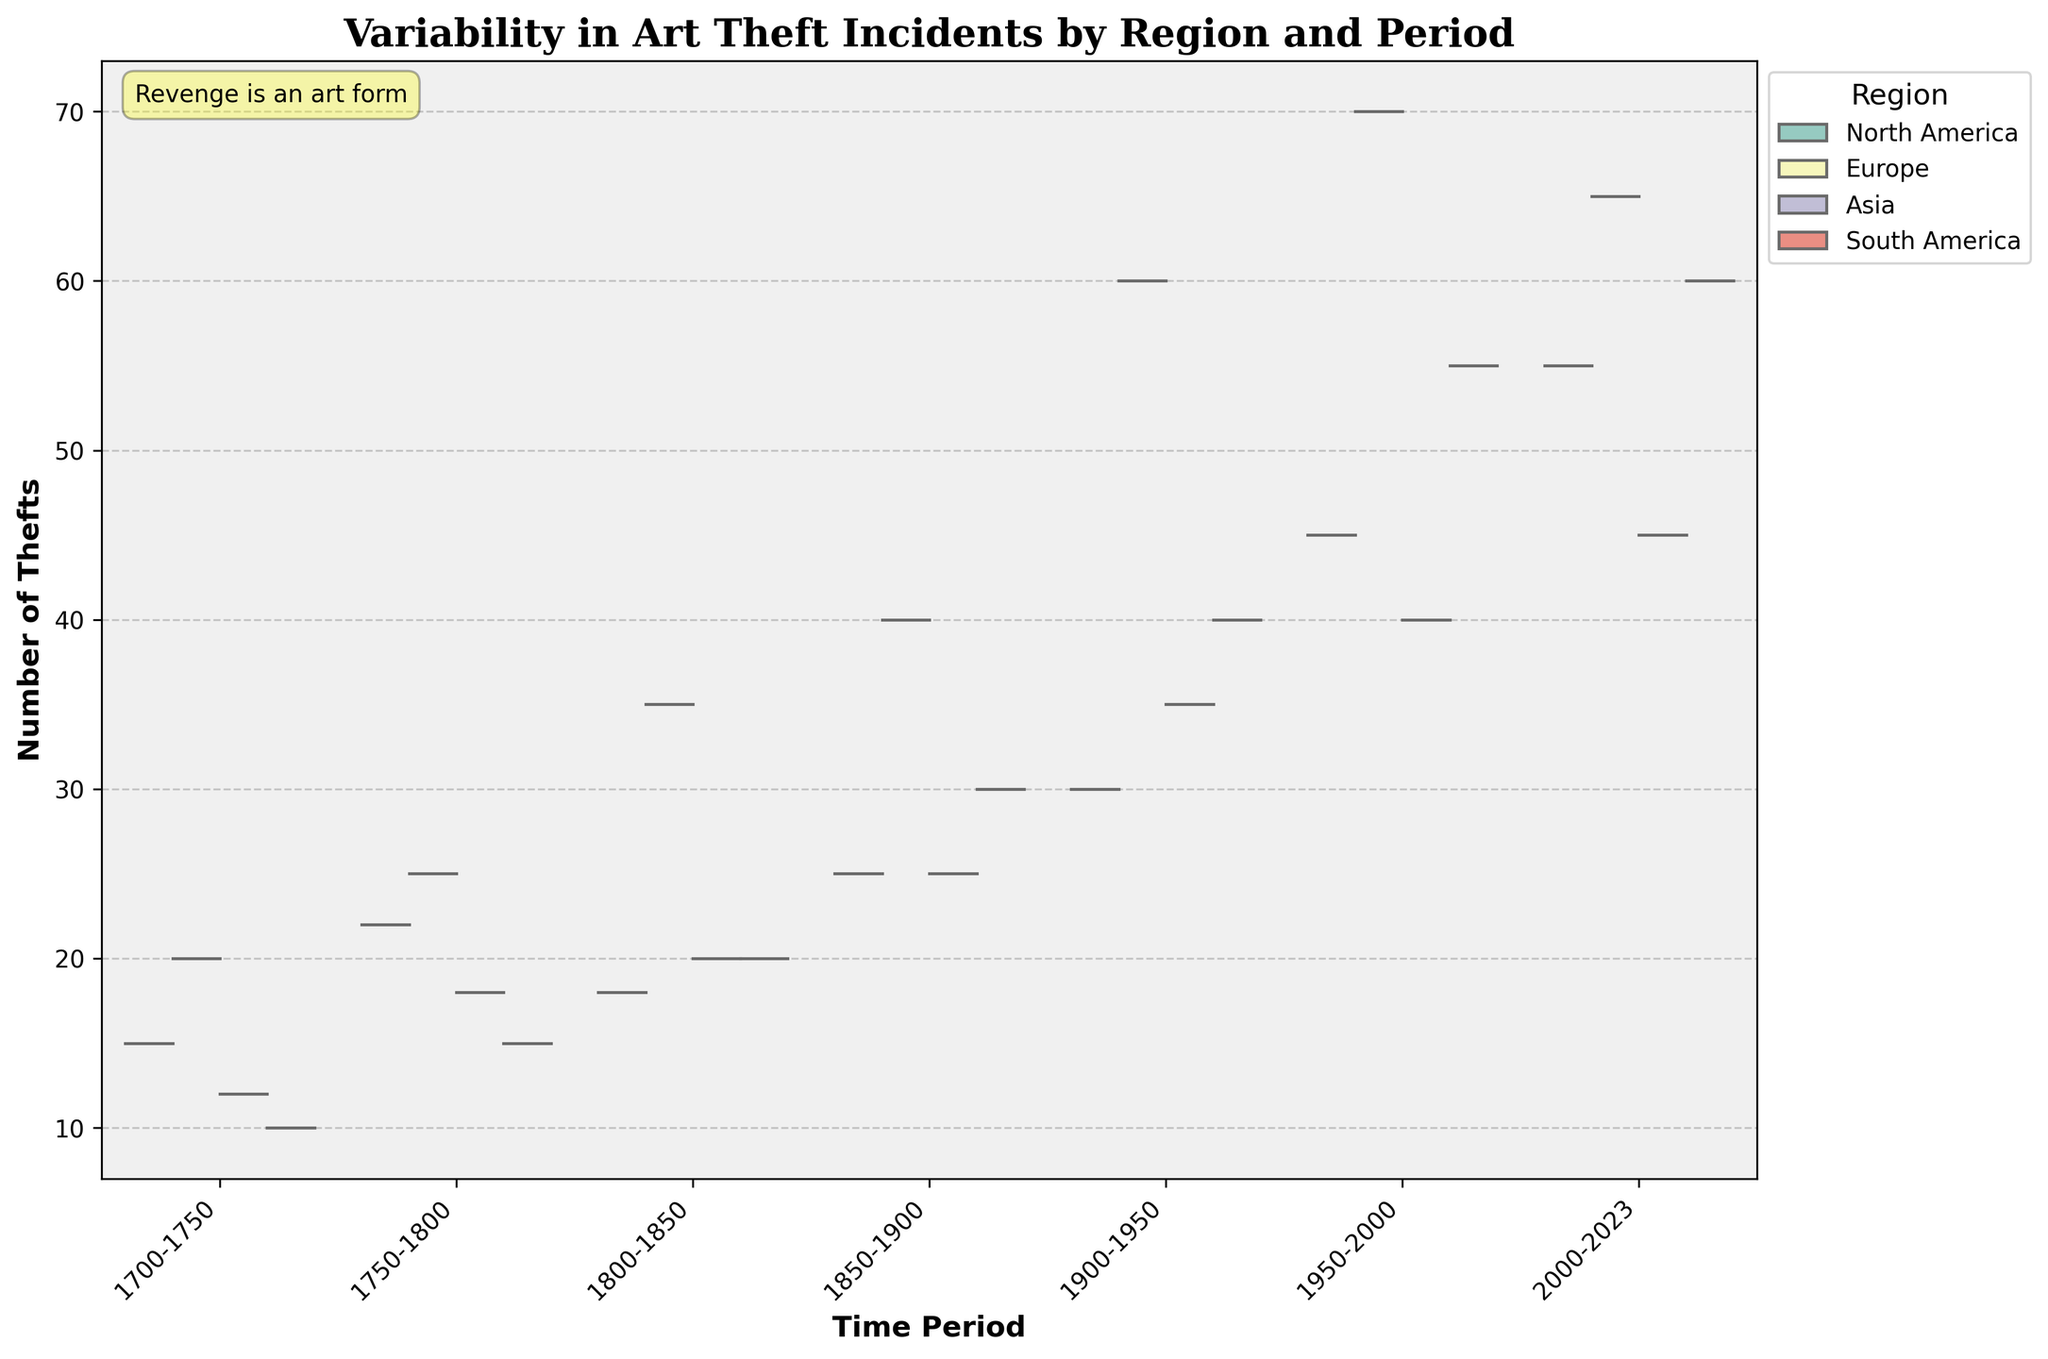What is the title of the plot? The title is displayed at the top of the plot and summarizes the main focus of the visualization, which is the variability in art theft incidents by region and period.
Answer: Variability in Art Theft Incidents by Region and Period Which region has the highest median number of thefts in the period 2000-2023? The violins provide a visual representation of the distribution. The median is indicated by the white dot inside each violin. The region with the highest median can be identified by looking at the position of these dots.
Answer: North America How do art theft incidents in Europe in the period 1950-2000 compare to those in Asia during the same period? By comparing the widths and heights of the violins for Europe and Asia during the period 1950-2000, we can see that Europe's violin is wider and extends higher, indicating both a higher number and greater variability of thefts.
Answer: Europe has higher and more variable thefts Which time period shows the greatest increase in art theft incidents in North America? By observing the change in the height of the violins over different periods for North America, the period with the steepest increase in height, indicating a significant rise in thefts, can be identified.
Answer: 1950-2000 Are there any regions where the number of art thefts decreased in the most recent periods? By looking at the last two periods (1950-2000 and 2000-2023) for each region and comparing the heights of the violins, we can determine if there is a decrease in any region.
Answer: Europe How does the distribution of art theft incidents in South America during the period 1900-1950 compare to the period 1950-2000? By comparing the widths and heights of the violins for South America during these periods, it can be seen that the later period has a much wider violin, indicating an increase in the number and variability of thefts.
Answer: More and more variable in 1950-2000 Which region and period combination has the most concentrated number of art thefts (least variability)? Looking for the smallest and narrowest violin across all regions and periods will show the combination with the least variability.
Answer: South America, 1700-1750 Is the number of art theft incidents more evenly distributed across periods in Europe or North America? By observing the overall shape and uniformity of the violins for Europe and North America, we can see which region has a steadier distribution across periods. Europe's violins are more uniform in shape compared to North America's, which display more variation.
Answer: Europe What does the text box in the figure say? The text box is located in the top left corner of the figure and contains a message relating to the theme of the plot.
Answer: Revenge is an art form 